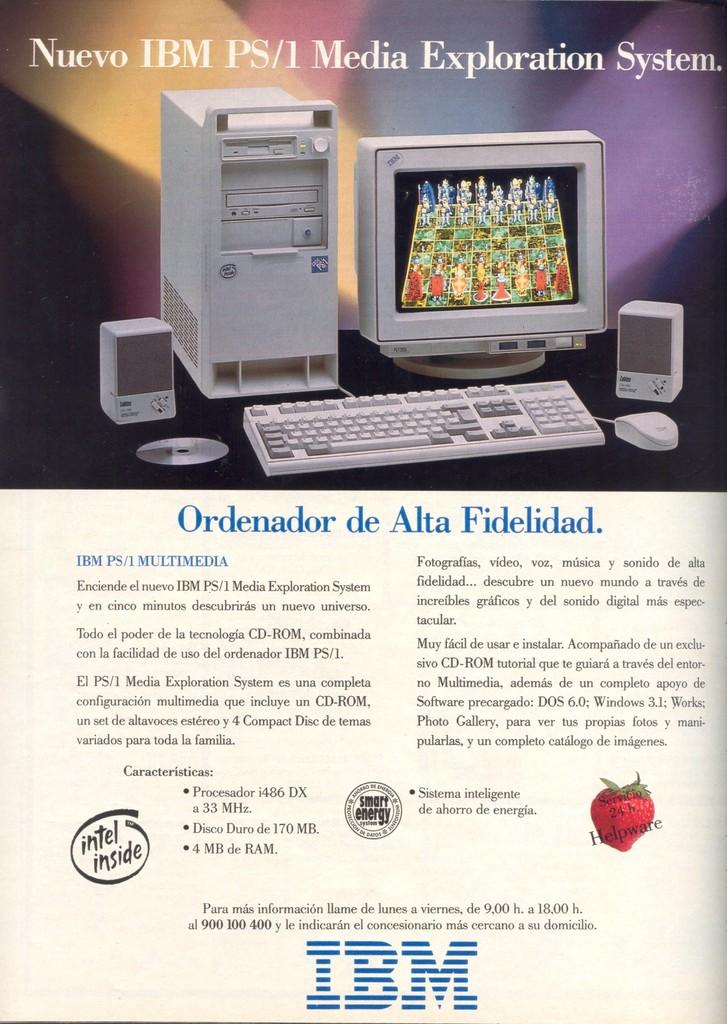Provide a one-sentence caption for the provided image. An IBM advertisement shows IBM PS/1 and claims to have Intel inside. 